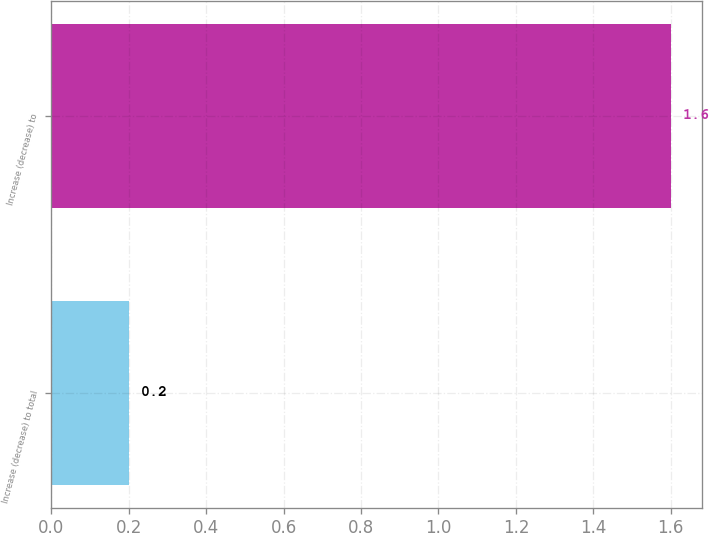Convert chart to OTSL. <chart><loc_0><loc_0><loc_500><loc_500><bar_chart><fcel>Increase (decrease) to total<fcel>Increase (decrease) to<nl><fcel>0.2<fcel>1.6<nl></chart> 